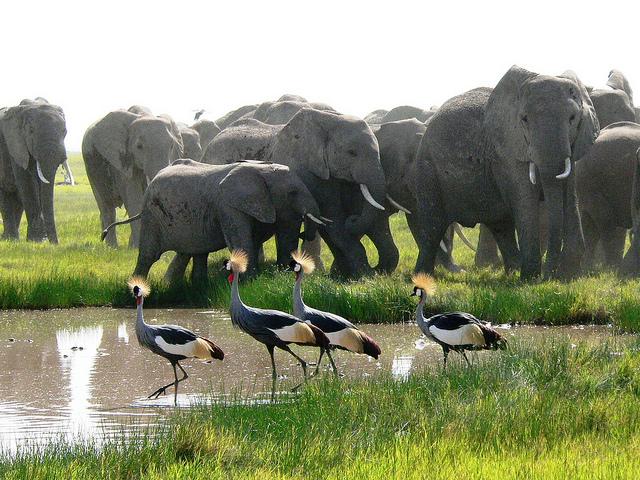Where are the birds?
Keep it brief. Water. Are the birds wet?
Give a very brief answer. Yes. How many elephants?
Short answer required. 15. 